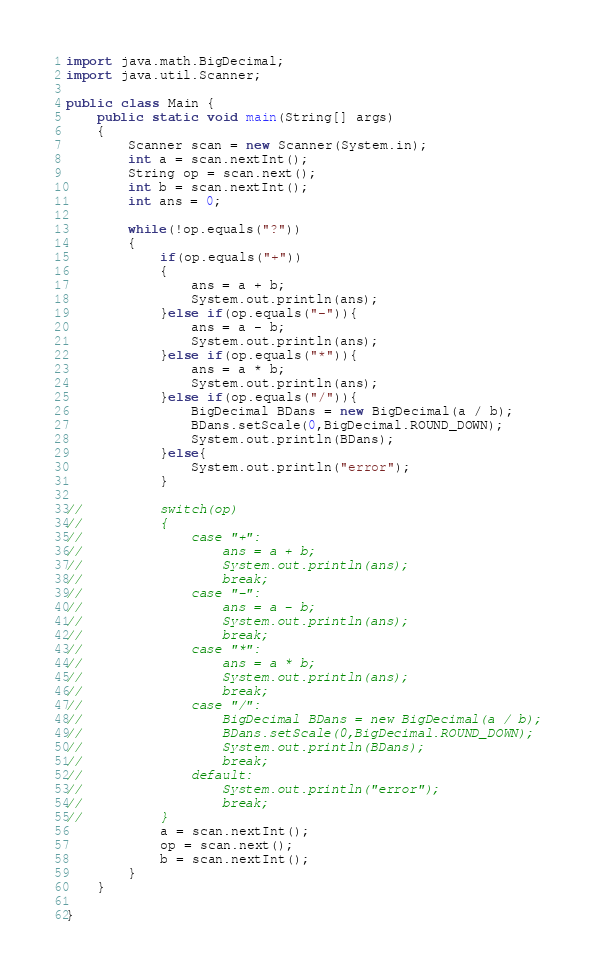<code> <loc_0><loc_0><loc_500><loc_500><_Java_>import java.math.BigDecimal;
import java.util.Scanner;

public class Main {
	public static void main(String[] args)
	{
		Scanner scan = new Scanner(System.in);
		int a = scan.nextInt();
		String op = scan.next();
		int b = scan.nextInt();
		int ans = 0;

		while(!op.equals("?"))
		{
			if(op.equals("+"))
			{
				ans = a + b;
				System.out.println(ans);
			}else if(op.equals("-")){
				ans = a - b;
				System.out.println(ans);
			}else if(op.equals("*")){
				ans = a * b;
				System.out.println(ans);
			}else if(op.equals("/")){
				BigDecimal BDans = new BigDecimal(a / b);
				BDans.setScale(0,BigDecimal.ROUND_DOWN);
				System.out.println(BDans);
			}else{
				System.out.println("error");
			}
			
//			switch(op)
//			{
//				case "+":
//					ans = a + b;
//					System.out.println(ans);
//					break;
//				case "-":
//					ans = a - b;
//					System.out.println(ans);
//					break;
//				case "*":
//					ans = a * b;
//					System.out.println(ans);
//					break;
//				case "/":
//					BigDecimal BDans = new BigDecimal(a / b);
//					BDans.setScale(0,BigDecimal.ROUND_DOWN);
//					System.out.println(BDans);
//					break;
//				default:
//					System.out.println("error");
//					break;
//			}
			a = scan.nextInt();
			op = scan.next();
			b = scan.nextInt();
		}
	}

}</code> 